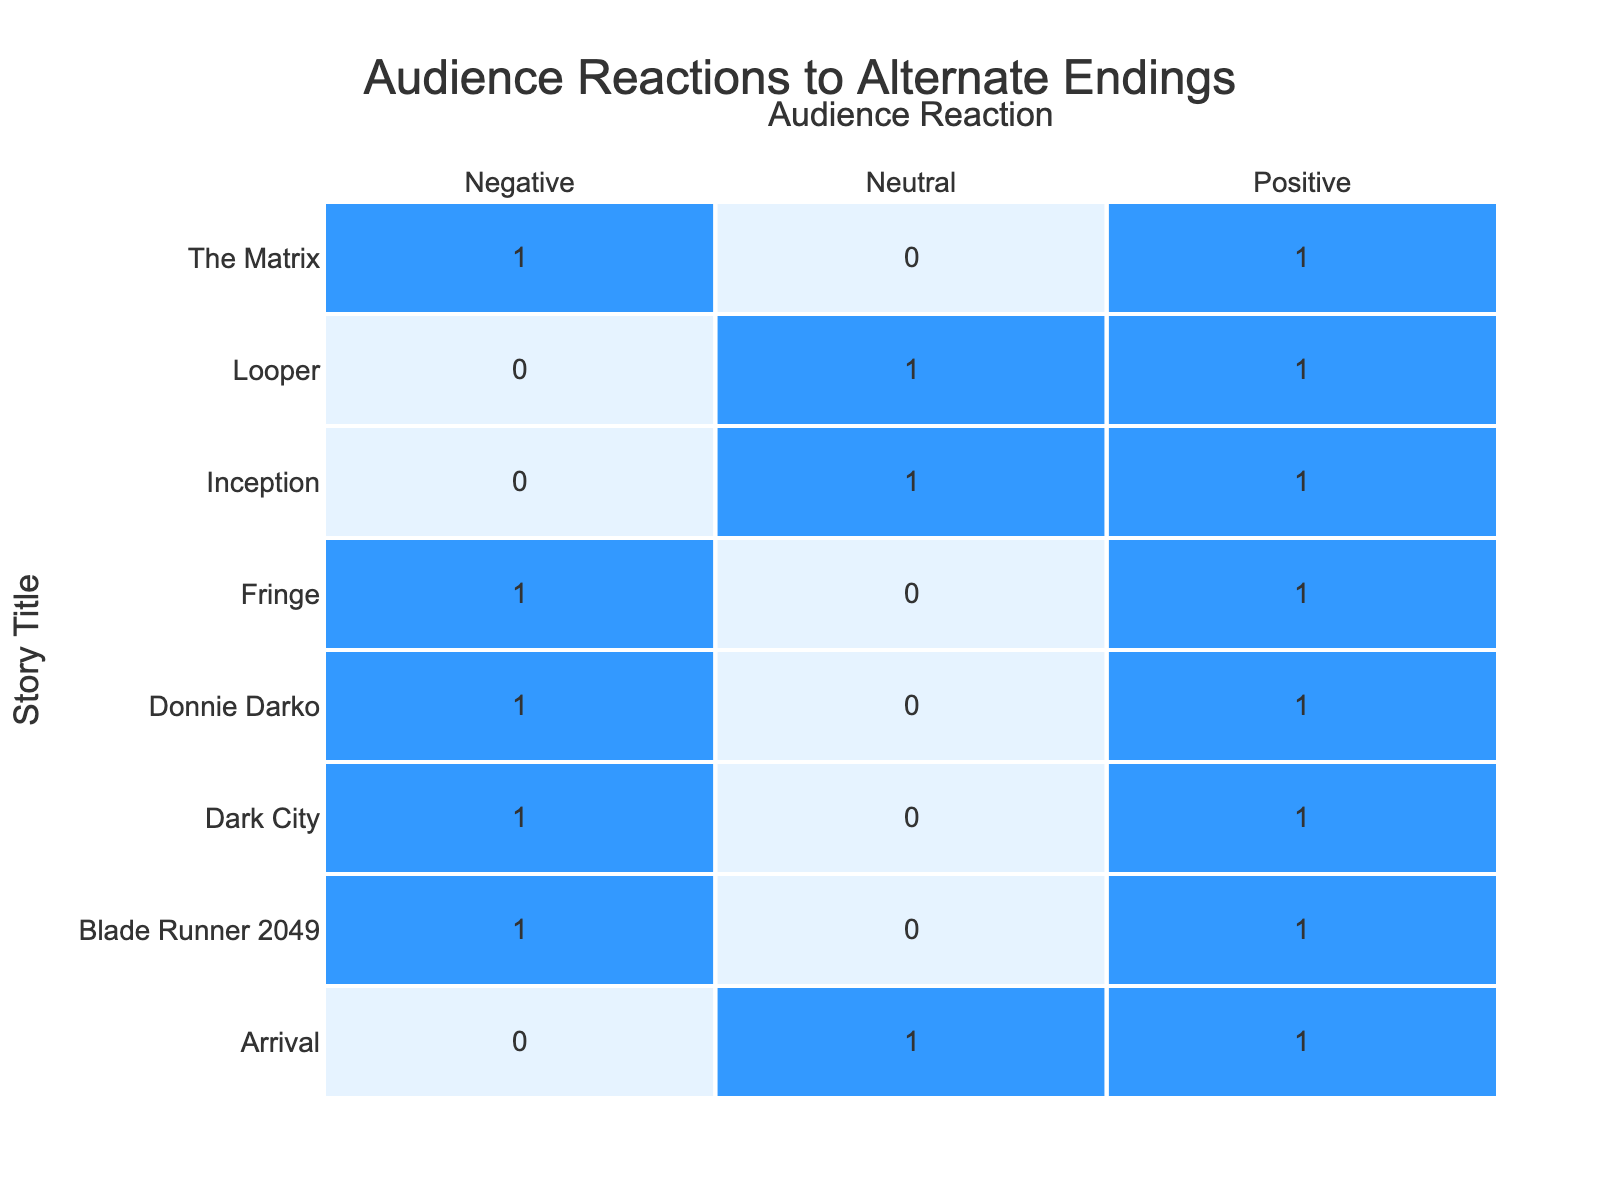What is the total number of positive audience reactions across all stories? To find the total positive reactions, we count all occurrences of "Positive" in the Audience Reaction column. Looking through the data, we find that "Blade Runner 2049", "Inception", "Donnie Darko", "Arrival", "The Matrix", "Fringe", "Looper", and "Dark City" all received positive reactions. In total, there are 7 positive reactions.
Answer: 7 Which story has the highest count of negative audience reactions? We need to look for the story with the most occurrences of "Negative". From the data, "Blade Runner 2049", "Donnie Darko", "The Matrix", and "Fringe" each have 1 negative reaction, while "Dark City" has 0. Thus, there is a tie between the stories with 1 negative reaction.
Answer: Blade Runner 2049, Donnie Darko, The Matrix, Fringe What is the difference in the number of neutral reactions between "Inception" and "Looper"? "Inception" has 1 neutral reaction (A), while "Looper" also has 1 neutral reaction (A). The difference between these two counts is calculated as 1 - 1 = 0.
Answer: 0 Did "Arrival" have any negative audience reactions? By examining the data for "Arrival", we find no occurrences of "Negative" in its audience reactions. Since only "Positive" and "Neutral" reactions are present, the answer is clearly no.
Answer: No Which story had a positive reaction with the alternate ending "D"? From the data, we see "Blade Runner 2049" has a negative reaction with ending "D", and "Dark City" had a positive reaction with the same ending. Therefore, the story that had a positive reaction with ending "D" is "Dark City".
Answer: Dark City What is the total count of alternating endings that received a neutral reaction? We look for any occurrences of "Neutral" in the Audience Reaction column. The stories with neutral reactions are "Inception" (1 neutral) and "Looper" (1 neutral), for a total count of 2 neutral reactions from different stories.
Answer: 2 Is it true that "Looper" received more positive reactions than "Fringe"? For "Looper", there is 1 positive reaction, while for "Fringe", there is also 1 positive reaction. Since both have an equal number of positive reactions, the statement is false.
Answer: No How many stories had both positive and negative audience reactions? The stories that had both a positive and a negative reaction are "Blade Runner 2049", "Donnie Darko", and "The Matrix". Each of these stories showcases differing audience reactions, indicating the concept of choice in their altered endings. Therefore, the total is 3.
Answer: 3 What is the ratio of positive to negative reactions for "Donnie Darko"? "Donnie Darko" has 1 positive reaction and 1 negative reaction. The ratio is calculated as positive reactions (1) to negative reactions (1), ultimately giving a ratio of 1:1.
Answer: 1:1 